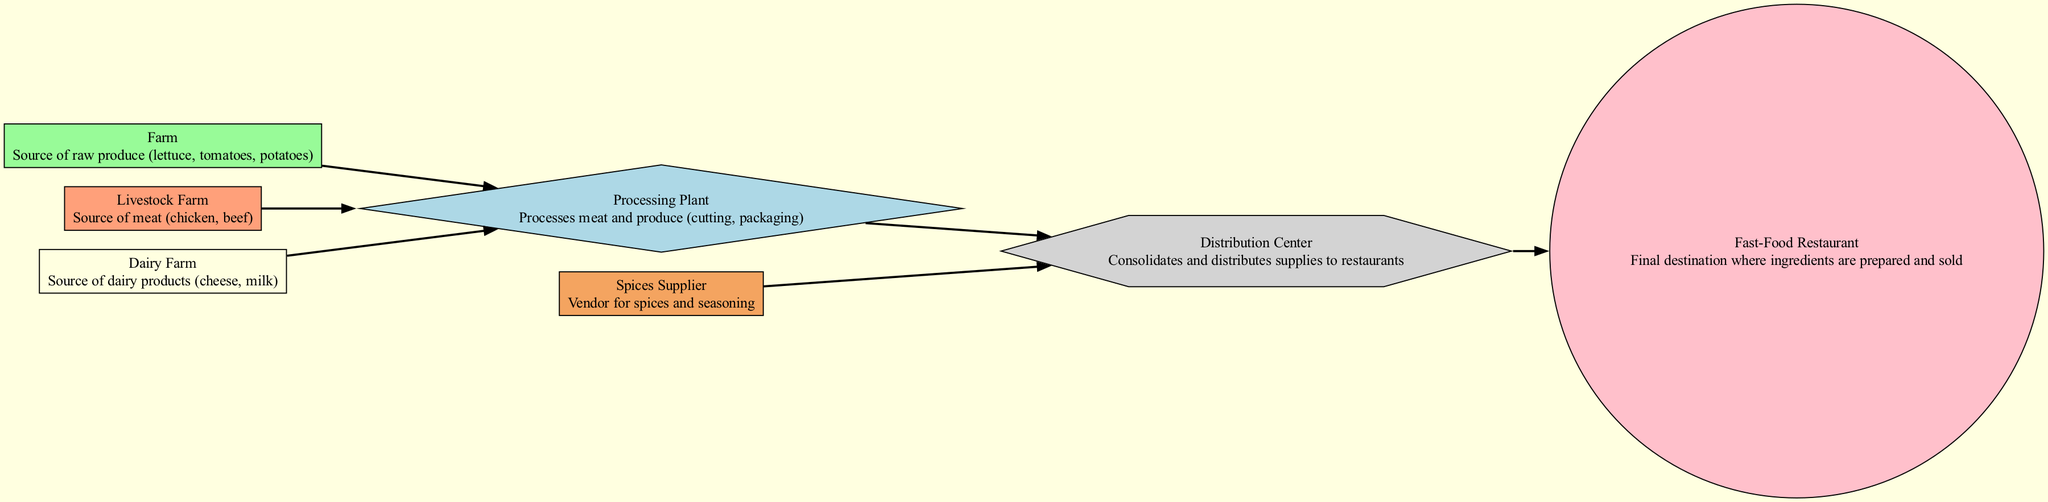What is the starting point of the food chain? The diagram indicates that the food chain begins at the "Farm," which is the source of raw produce.
Answer: Farm How many types of suppliers are there in the diagram? The diagram lists four types of suppliers: Farm, Livestock Farm, Dairy Farm, and Spices Supplier.
Answer: Four Which node represents the final destination of the food chain? The "Fast-Food Restaurant" node is the last node in the diagram, indicating where the ingredients are ultimately prepared and sold.
Answer: Fast-Food Restaurant What processes do the "Processing Plant" perform? The "Processing Plant" processes both meat and produce, which includes cutting and packaging them before distribution.
Answer: Cutting and packaging What is the relationship between the “Spices Supplier” and the “Distribution Center”? The diagram shows that the "Spices Supplier" supplies spices and seasoning directly to the "Distribution Center."
Answer: Supplies How many nodes directly send supplies to the “Distribution Center”? The diagram indicates that three nodes supply ingredients to the "Distribution Center": Processing Plant and Spices Supplier.
Answer: Three Which ingredient source is responsible for dairy products in the food chain? The node labeled "Dairy Farm" indicates the source of dairy products such as cheese and milk.
Answer: Dairy Farm What type of farm provides meat according to the diagram? The "Livestock Farm" is identified in the diagram as the source of meat for the food chain.
Answer: Livestock Farm Which node connects the "Processing Plant" and the "Fast-Food Restaurant"? The "Distribution Center" acts as the intermediary node that connects both the "Processing Plant" and the "Fast-Food Restaurant."
Answer: Distribution Center 